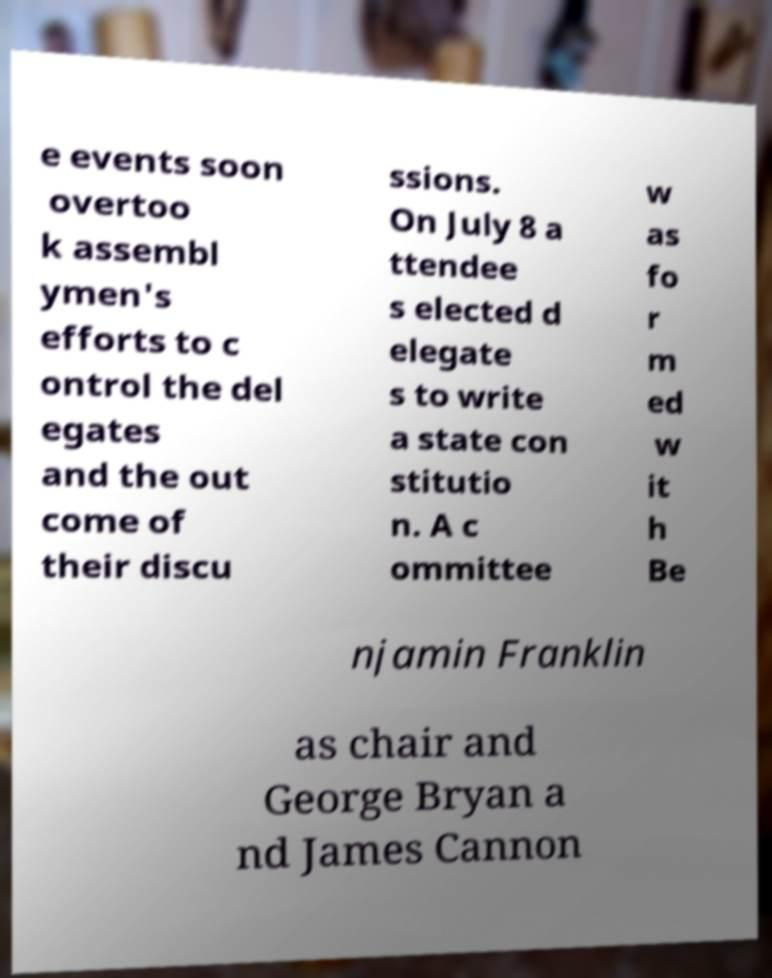There's text embedded in this image that I need extracted. Can you transcribe it verbatim? e events soon overtoo k assembl ymen's efforts to c ontrol the del egates and the out come of their discu ssions. On July 8 a ttendee s elected d elegate s to write a state con stitutio n. A c ommittee w as fo r m ed w it h Be njamin Franklin as chair and George Bryan a nd James Cannon 